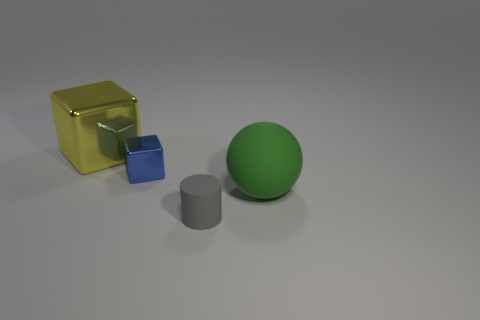Add 2 red cylinders. How many objects exist? 6 Subtract all cylinders. How many objects are left? 3 Subtract all blue cubes. How many cubes are left? 1 Subtract 0 brown cubes. How many objects are left? 4 Subtract 2 cubes. How many cubes are left? 0 Subtract all brown spheres. Subtract all yellow cubes. How many spheres are left? 1 Subtract all red spheres. How many yellow cubes are left? 1 Subtract all blue things. Subtract all blue blocks. How many objects are left? 2 Add 4 green things. How many green things are left? 5 Add 2 metallic blocks. How many metallic blocks exist? 4 